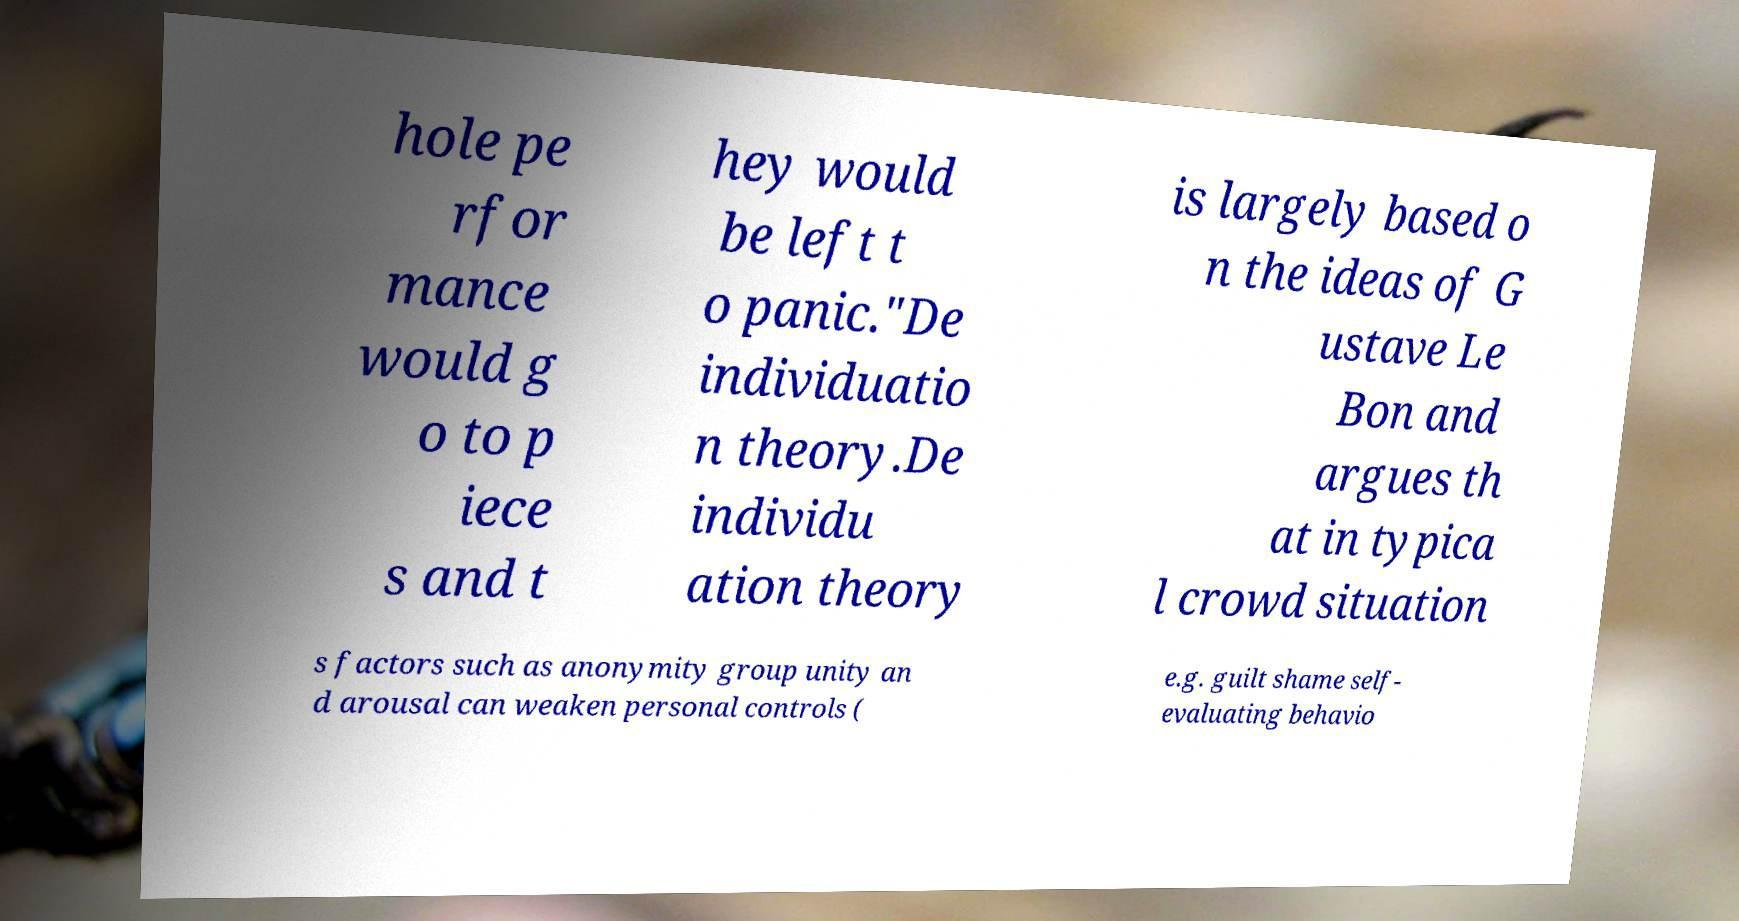There's text embedded in this image that I need extracted. Can you transcribe it verbatim? hole pe rfor mance would g o to p iece s and t hey would be left t o panic."De individuatio n theory.De individu ation theory is largely based o n the ideas of G ustave Le Bon and argues th at in typica l crowd situation s factors such as anonymity group unity an d arousal can weaken personal controls ( e.g. guilt shame self- evaluating behavio 